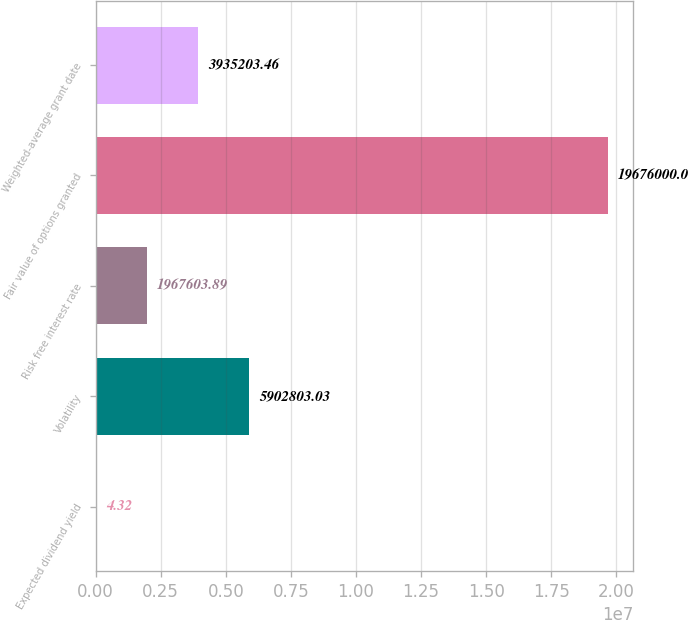<chart> <loc_0><loc_0><loc_500><loc_500><bar_chart><fcel>Expected dividend yield<fcel>Volatility<fcel>Risk free interest rate<fcel>Fair value of options granted<fcel>Weighted-average grant date<nl><fcel>4.32<fcel>5.9028e+06<fcel>1.9676e+06<fcel>1.9676e+07<fcel>3.9352e+06<nl></chart> 